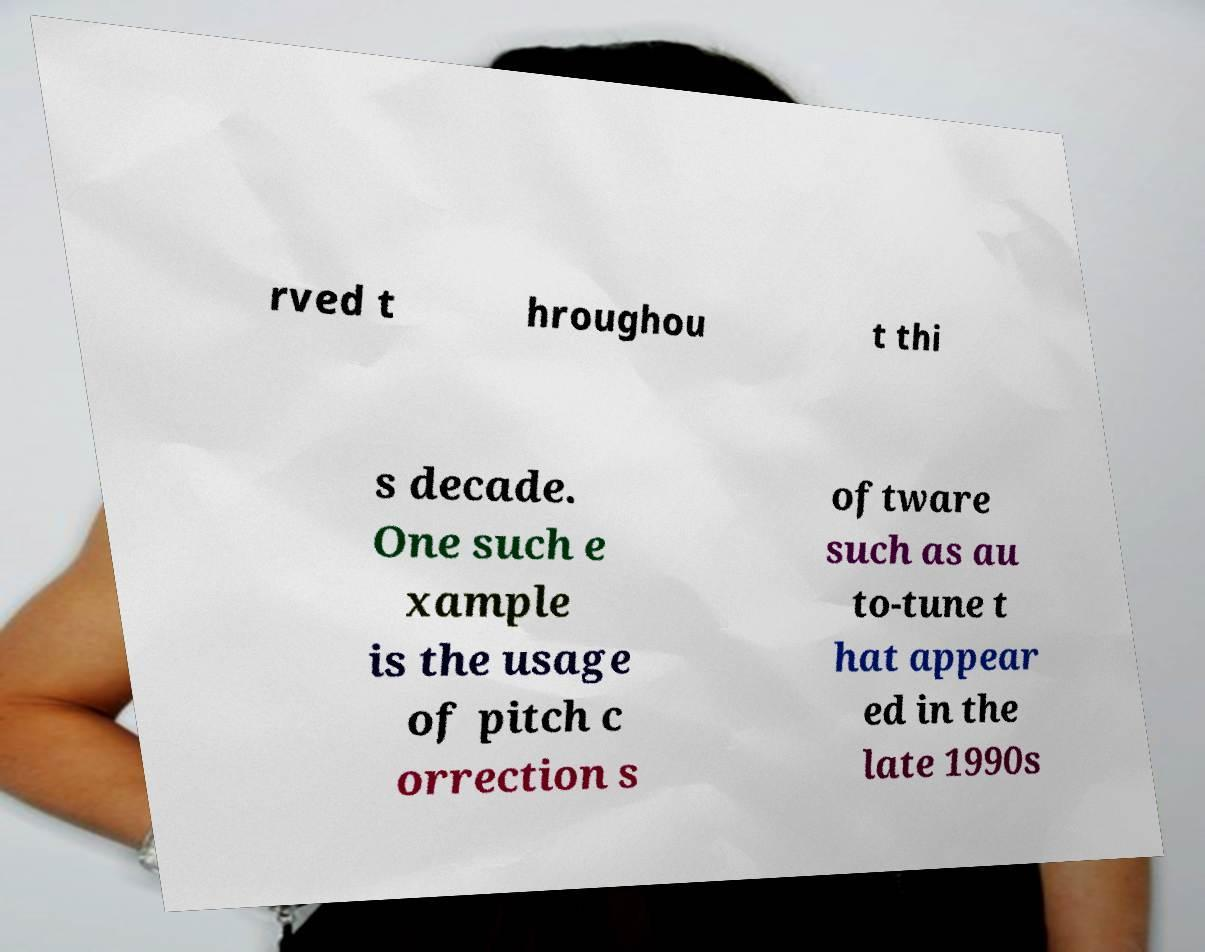There's text embedded in this image that I need extracted. Can you transcribe it verbatim? rved t hroughou t thi s decade. One such e xample is the usage of pitch c orrection s oftware such as au to-tune t hat appear ed in the late 1990s 